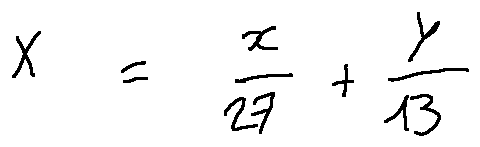<formula> <loc_0><loc_0><loc_500><loc_500>X = \frac { x } { 2 7 } + \frac { y } { 1 3 }</formula> 